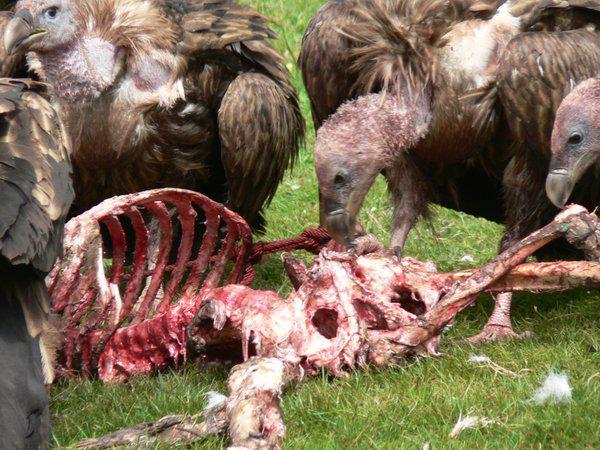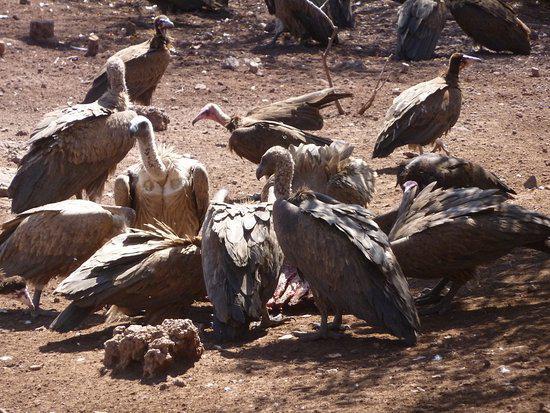The first image is the image on the left, the second image is the image on the right. Analyze the images presented: Is the assertion "The left image has the exposed ribcage of an animal carcass." valid? Answer yes or no. Yes. The first image is the image on the left, the second image is the image on the right. For the images shown, is this caption "There is a total of 1 fox with 1 or more buzzards." true? Answer yes or no. No. 